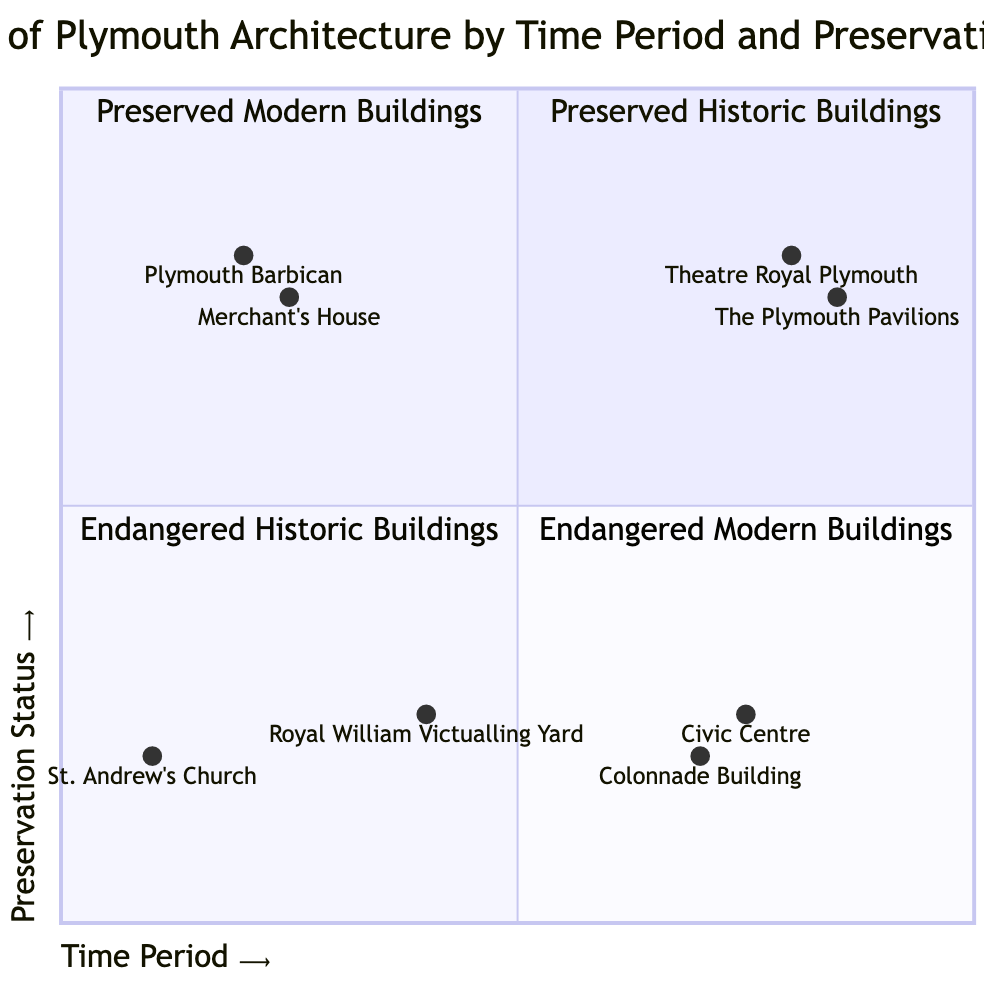What notable building from the 16th century appears in the "Preserved Historic Buildings" quadrant? The "Preserved Historic Buildings" quadrant contains notable buildings from the 16th century. Among them, "Plymouth Barbican" and "Merchant's House" are listed. Therefore, both are significant but choosing one, the "Plymouth Barbican" is a prominent example.
Answer: Plymouth Barbican How many buildings are categorized as "Endangered Modern Buildings"? The "Endangered Modern Buildings" quadrant includes two buildings: "Colonnade Building" and "Civic Centre." Therefore, the total number of buildings in this category is two.
Answer: 2 Which century does the "Royal William Victualling Yard" belong to? The "Royal William Victualling Yard" is identified in the "Endangered Historic Buildings" quadrant with a specified time period of the 19th century. Thus, it belongs to that century.
Answer: 19th Century Are there more preserved buildings from the modern or historic category? The "Preserved Modern Buildings" quadrant contains two buildings: "Theatre Royal Plymouth" and "The Plymouth Pavilions." The "Preserved Historic Buildings" quadrant also has two buildings: "Plymouth Barbican" and "Merchant's House." Since both categories have an equal count of two, there are not more preserved buildings in either category.
Answer: Neither Which building has the highest preservation status in the "Endangered" categories? Among the "Endangered Historic Buildings" is "St. Andrew's Church" and "Royal William Victualling Yard" labeled as endangered. In the "Endangered Modern Buildings," "Colonnade Building" and "Civic Centre" are classified likewise. Since all are categorized as "Endangered," none possesses a higher preservation status than the others.
Answer: All are endangered 